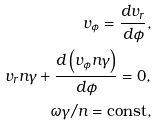<formula> <loc_0><loc_0><loc_500><loc_500>v _ { \phi } = \frac { d v _ { r } } { d \phi } , \\ v _ { r } n \gamma + \frac { d \left ( v _ { \phi } n \gamma \right ) } { d \phi } = 0 , \\ \omega \gamma / n = \text {const} ,</formula> 